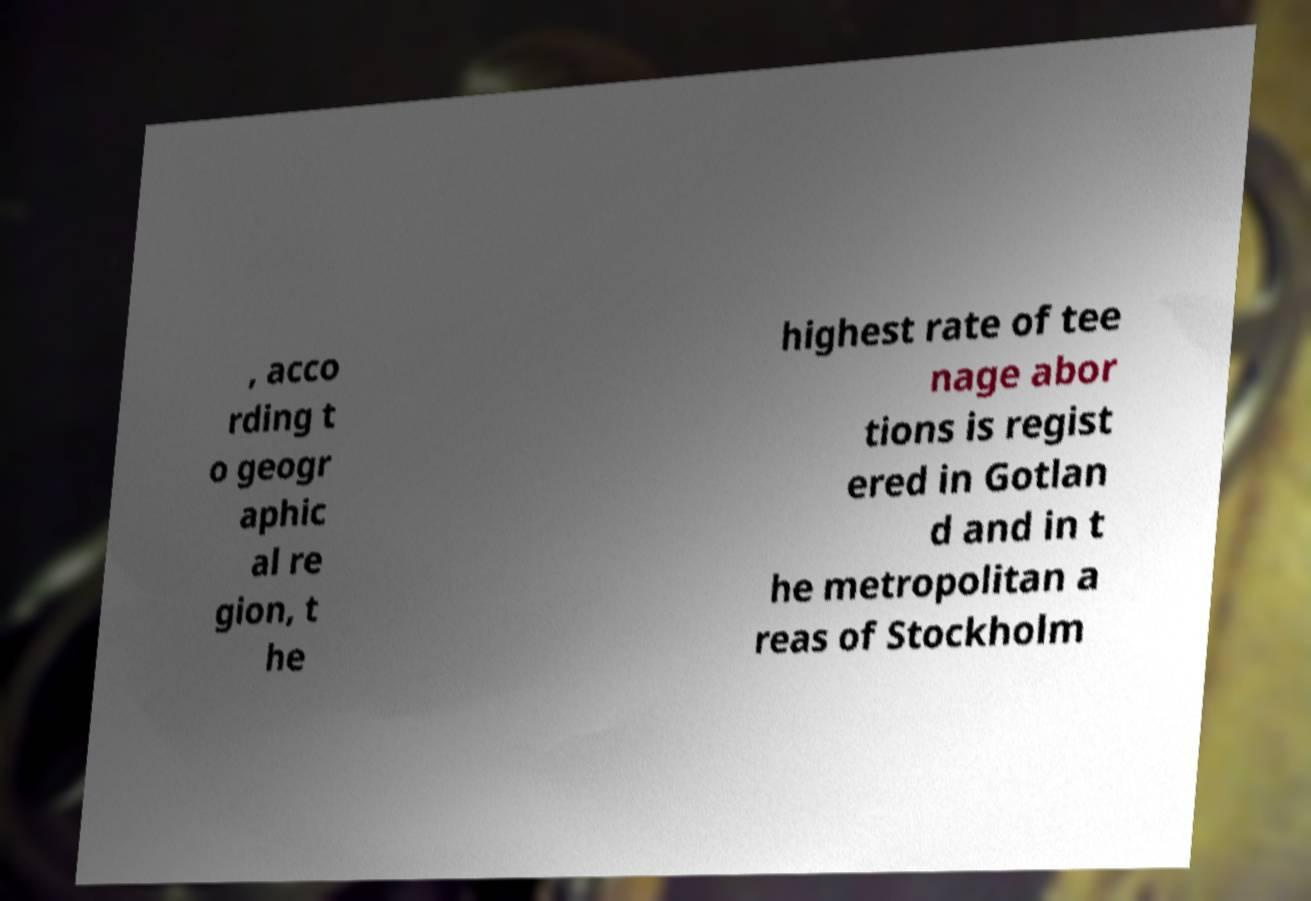For documentation purposes, I need the text within this image transcribed. Could you provide that? , acco rding t o geogr aphic al re gion, t he highest rate of tee nage abor tions is regist ered in Gotlan d and in t he metropolitan a reas of Stockholm 